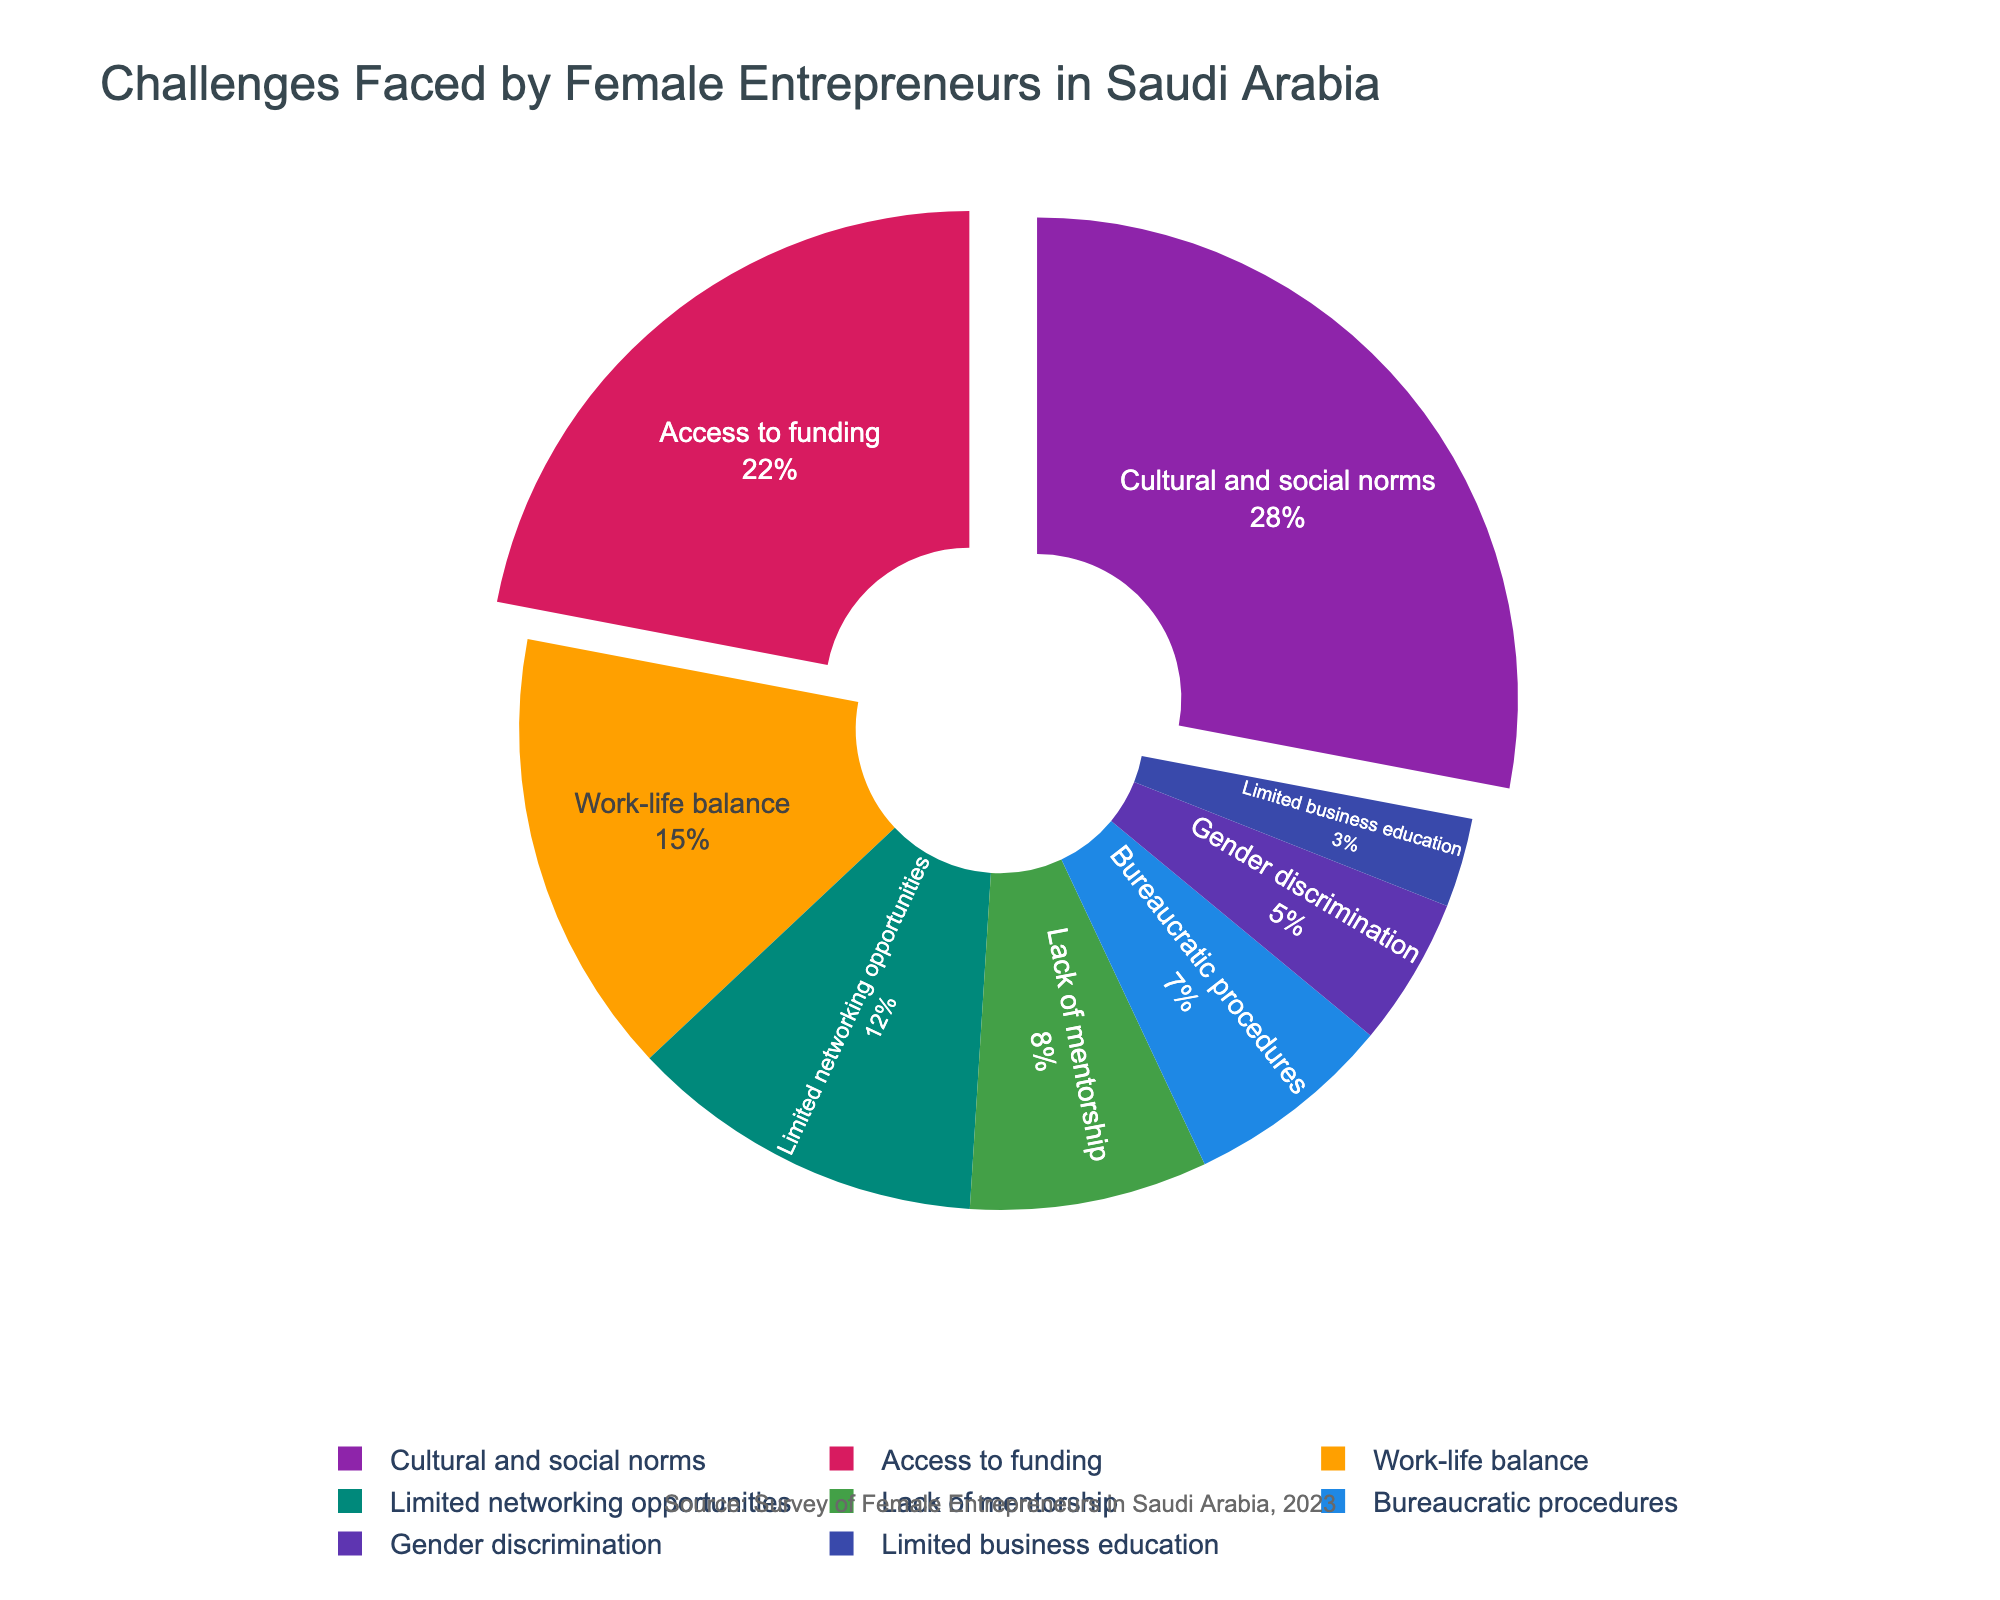What percentage of challenges faced by female entrepreneurs in Saudi Arabia is related to Cultural and social norms compared to Access to funding? Cultural and social norms account for 28% and Access to funding accounts for 22%. The difference is 28% - 22% = 6%.
Answer: 6% What is the total percentage of challenges accounted for by Limited networking opportunities and Gender discrimination? Adding the percentages for Limited networking opportunities (12%) and Gender discrimination (5%) gives 12% + 5% = 17%.
Answer: 17% Which challenge has the smallest percentage and what is its value? The challenge with the smallest percentage is Limited business education, with a value of 3%.
Answer: Limited business education, 3% How much more significant is Access to funding compared to Bureaucratic procedures? Access to funding is 22% and Bureaucratic procedures is 7%. The difference is 22% - 7% = 15%.
Answer: 15% What is the combined percentage of Work-life balance, Lack of mentorship, and Bureaucratic procedures? Adding the percentages of Work-life balance (15%), Lack of mentorship (8%), and Bureaucratic procedures (7%) gives 15% + 8% + 7% = 30%.
Answer: 30% Among the challenges, which are represented using red and green colors? Based on the described color scheme, red represents Access to funding and green represents Lack of mentorship. Thus, Access to funding is represented by red and Lack of mentorship by green.
Answer: Access to funding, Lack of mentorship Rank the challenges from the highest to the lowest percentage. The ranking is as follows: 
1. Cultural and social norms (28%)
2. Access to funding (22%)
3. Work-life balance (15%)
4. Limited networking opportunities (12%)
5. Lack of mentorship (8%)
6. Bureaucratic procedures (7%)
7. Gender discrimination (5%)
8. Limited business education (3%)
Answer: Cultural and social norms > Access to funding > Work-life balance > Limited networking opportunities > Lack of mentorship > Bureaucratic procedures > Gender discrimination > Limited business education If the combined percentage of Cultural and social norms and Work-life balance were distributed equally between them, what would be their new values? The total percentage is 28% + 15% = 43%. Dividing it equally between the two challenges gives 43% / 2 = 21.5% each.
Answer: 21.5% Which challenge is visually pulled out (separated) the furthest from the pie chart? The challenges pulled out (separated) are Cultural and social norms and Access to funding. Based on the figure, these are the segments represented further from the pie chart center.
Answer: Cultural and social norms, Access to funding 